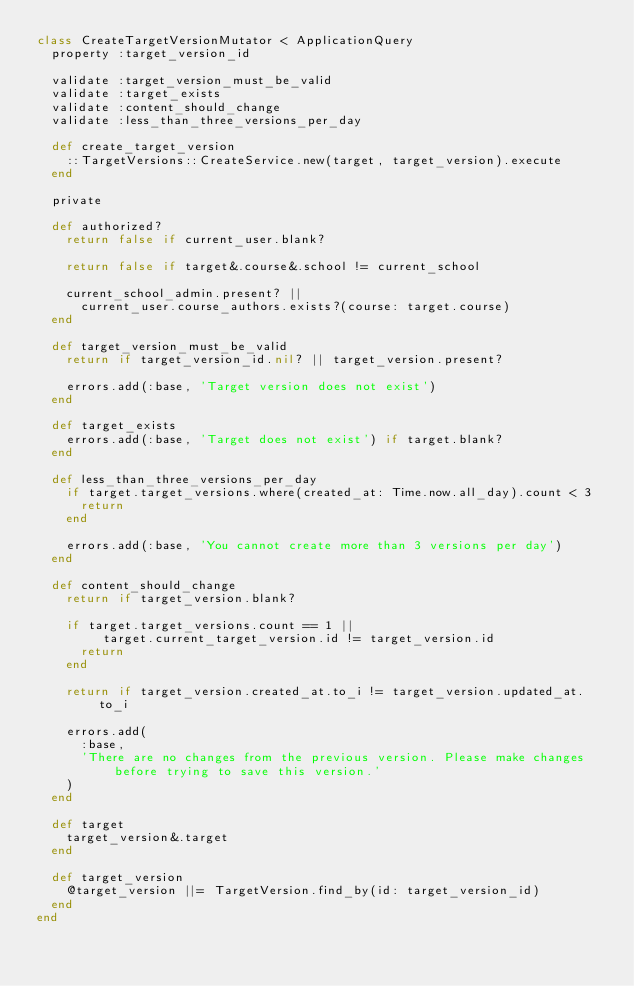<code> <loc_0><loc_0><loc_500><loc_500><_Ruby_>class CreateTargetVersionMutator < ApplicationQuery
  property :target_version_id

  validate :target_version_must_be_valid
  validate :target_exists
  validate :content_should_change
  validate :less_than_three_versions_per_day

  def create_target_version
    ::TargetVersions::CreateService.new(target, target_version).execute
  end

  private

  def authorized?
    return false if current_user.blank?

    return false if target&.course&.school != current_school

    current_school_admin.present? ||
      current_user.course_authors.exists?(course: target.course)
  end

  def target_version_must_be_valid
    return if target_version_id.nil? || target_version.present?

    errors.add(:base, 'Target version does not exist')
  end

  def target_exists
    errors.add(:base, 'Target does not exist') if target.blank?
  end

  def less_than_three_versions_per_day
    if target.target_versions.where(created_at: Time.now.all_day).count < 3
      return
    end

    errors.add(:base, 'You cannot create more than 3 versions per day')
  end

  def content_should_change
    return if target_version.blank?

    if target.target_versions.count == 1 ||
         target.current_target_version.id != target_version.id
      return
    end

    return if target_version.created_at.to_i != target_version.updated_at.to_i

    errors.add(
      :base,
      'There are no changes from the previous version. Please make changes before trying to save this version.'
    )
  end

  def target
    target_version&.target
  end

  def target_version
    @target_version ||= TargetVersion.find_by(id: target_version_id)
  end
end
</code> 